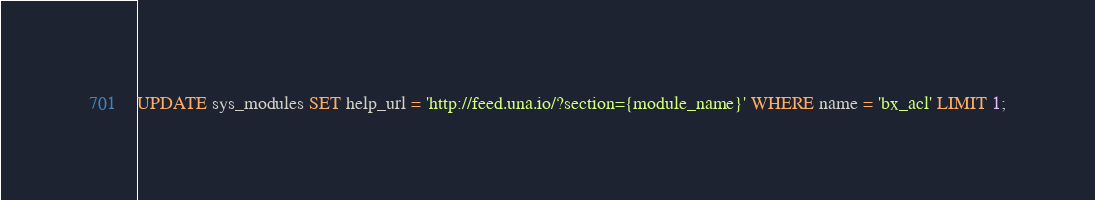Convert code to text. <code><loc_0><loc_0><loc_500><loc_500><_SQL_>UPDATE sys_modules SET help_url = 'http://feed.una.io/?section={module_name}' WHERE name = 'bx_acl' LIMIT 1;
</code> 